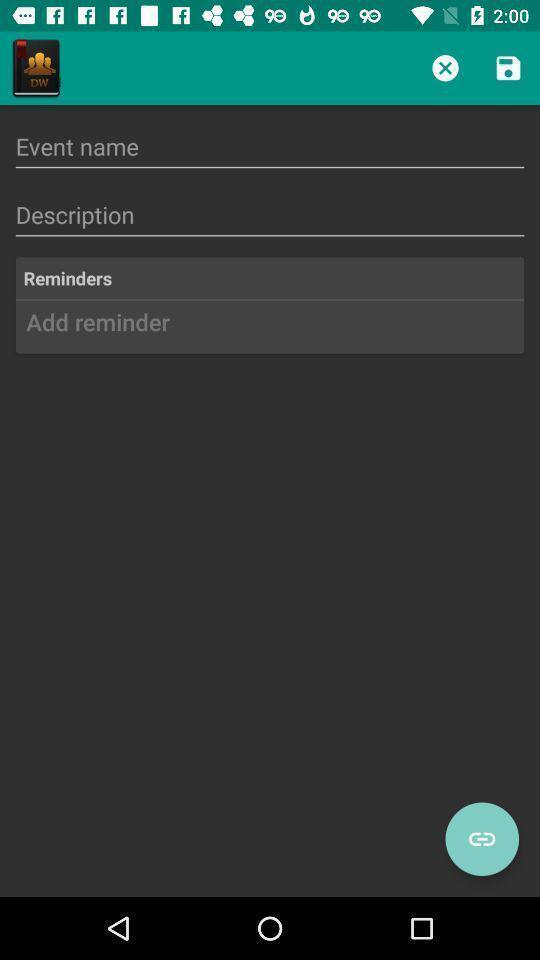Provide a description of this screenshot. Screen showing to add event details. 